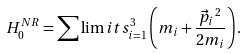<formula> <loc_0><loc_0><loc_500><loc_500>H ^ { N R } _ { 0 } = \sum \lim i t s _ { i = 1 } ^ { 3 } \left ( m _ { i } + \frac { \vec { p } _ { i } \, ^ { 2 } } { 2 m _ { i } } \right ) .</formula> 